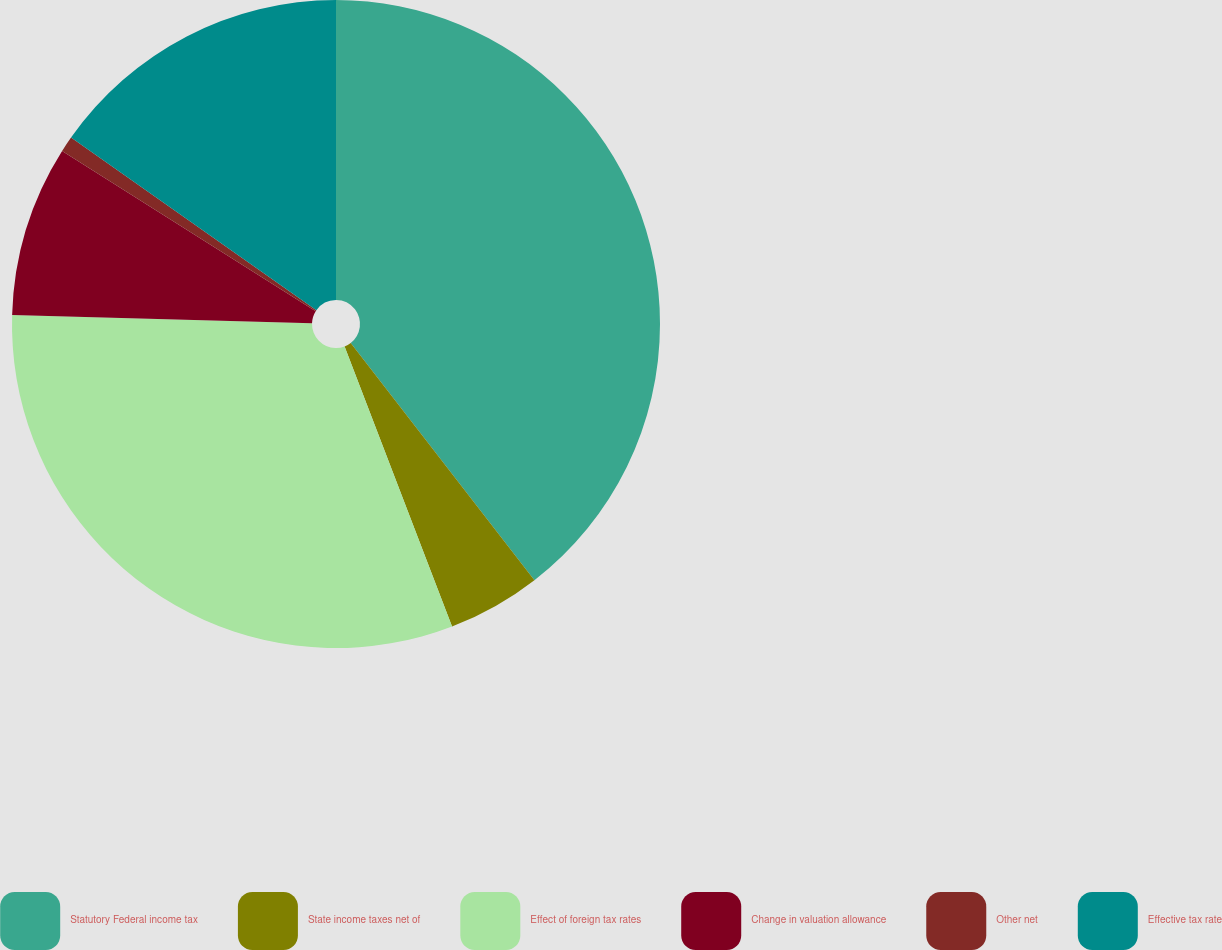Convert chart. <chart><loc_0><loc_0><loc_500><loc_500><pie_chart><fcel>Statutory Federal income tax<fcel>State income taxes net of<fcel>Effect of foreign tax rates<fcel>Change in valuation allowance<fcel>Other net<fcel>Effective tax rate<nl><fcel>39.51%<fcel>4.66%<fcel>31.27%<fcel>8.53%<fcel>0.79%<fcel>15.24%<nl></chart> 